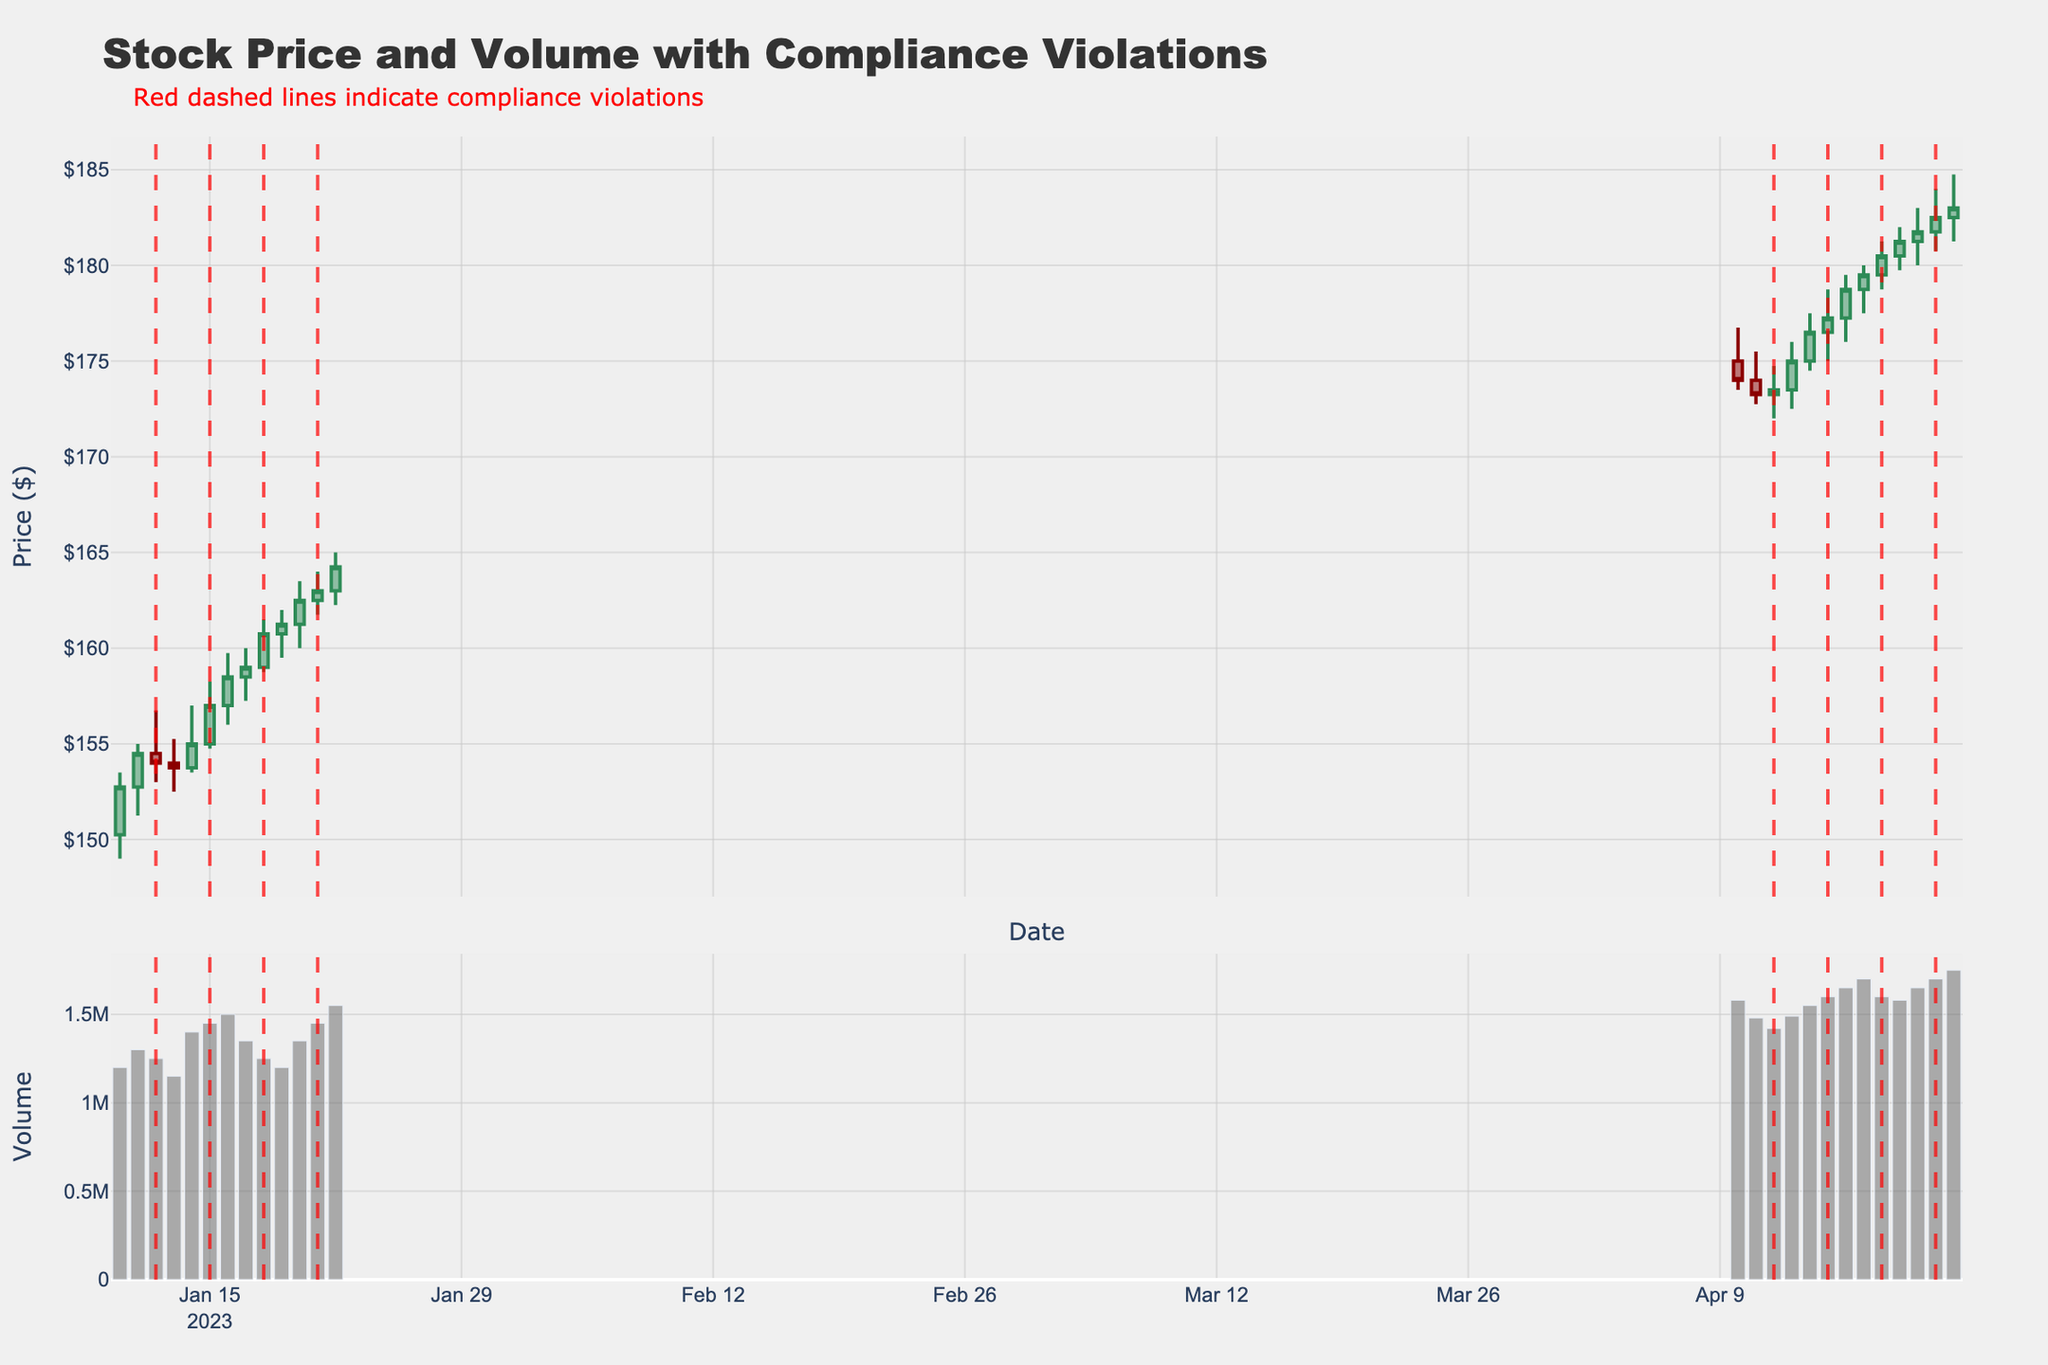What is the title of the figure? The title is usually found at the top of the figure. Here, it reads "Stock Price and Volume with Compliance Violations".
Answer: Stock Price and Volume with Compliance Violations How many compliance violations are highlighted in the figure? Compliance violations are indicated by red dashed vertical lines. By counting these lines, we can see there are 6 violations.
Answer: 6 What trend do you observe in the stock price from January 10 to January 22? Observing the candlestick plot for the specified dates, the stock shows an overall upward trend starting from around $152.75 and closing at around $164.25.
Answer: Upward trend On which dates during April does the stock price show compliance violations? Compliance violations are highlighted with red dashed vertical lines. In April, these lines appear on April 12, 15, 18, and 21.
Answer: April 12, 15, 18, 21 How does the trading volume compare on the dates with compliance violations versus those without, during January? By looking at the bar chart for January, we can compare the heights of the bars with red vertical lines to those without. On dates with violations (January 12 and 15), the volumes are 1,250,000 and 1,450,000. Dates without violations range from 1,150,000 to 1,400,000, meaning the volume is generally higher on dates with violations.
Answer: Higher on violation dates Which date shows the highest close price in April, and what is that price? Checking the candlestick tops in April, the highest closing price occurred on April 22 at $183.00.
Answer: April 22, $183.00 Was there an increase or decrease in stock price on January 13th, compared to the open price on the same day? Referencing the candlestick for January 13, the open price is $154.00, and the close price is $153.75, indicating a slight decrease.
Answer: Decrease What pattern can be observed in the candlestick shapes (e.g., increasing/decreasing) around dates with compliance violations? Observing the candlestick shapes around compliance violation dates, we can see a mixture of both increasing (green) and decreasing (red) candles, suggesting no clear pattern specific to violations.
Answer: No clear pattern What is the approximate price range (difference between high and low) on the date with the highest trading volume in April? The date with the highest trading volume in April is April 22 with 1,750,000. The high is $184.75 and the low is $181.25, making the range approximately $3.50.
Answer: $3.50 How many days show an increasing stock price (closing higher than opening) during January? By counting the green candles (indicating price increase), we find there are 5 such days in January.
Answer: 5 